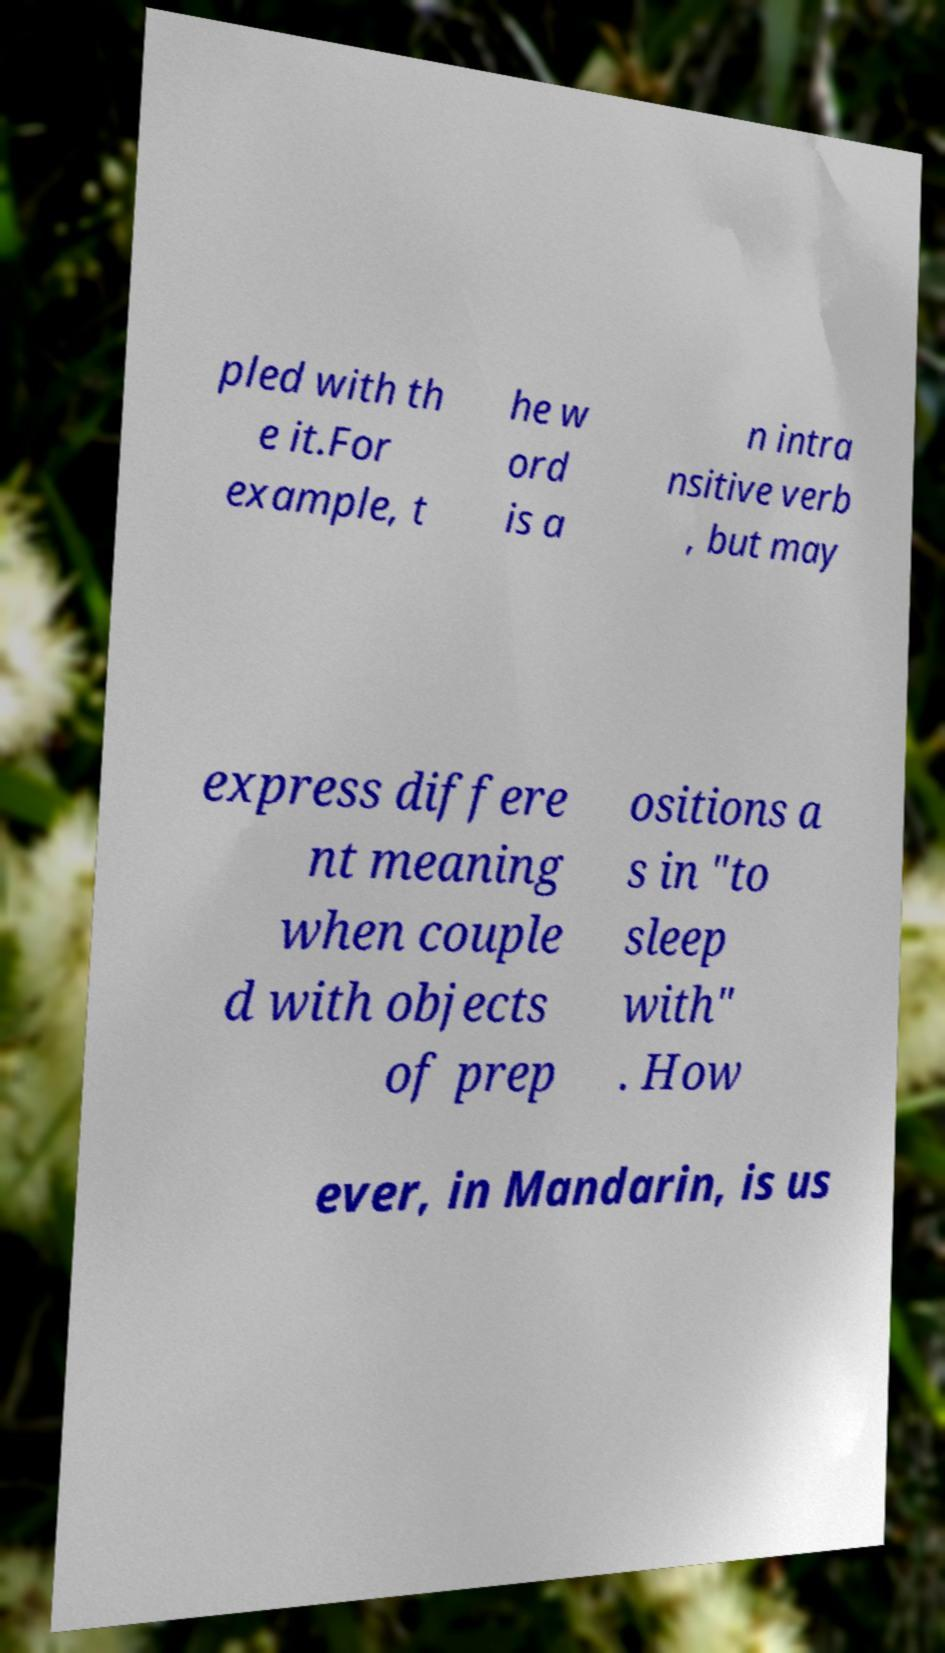What messages or text are displayed in this image? I need them in a readable, typed format. pled with th e it.For example, t he w ord is a n intra nsitive verb , but may express differe nt meaning when couple d with objects of prep ositions a s in "to sleep with" . How ever, in Mandarin, is us 